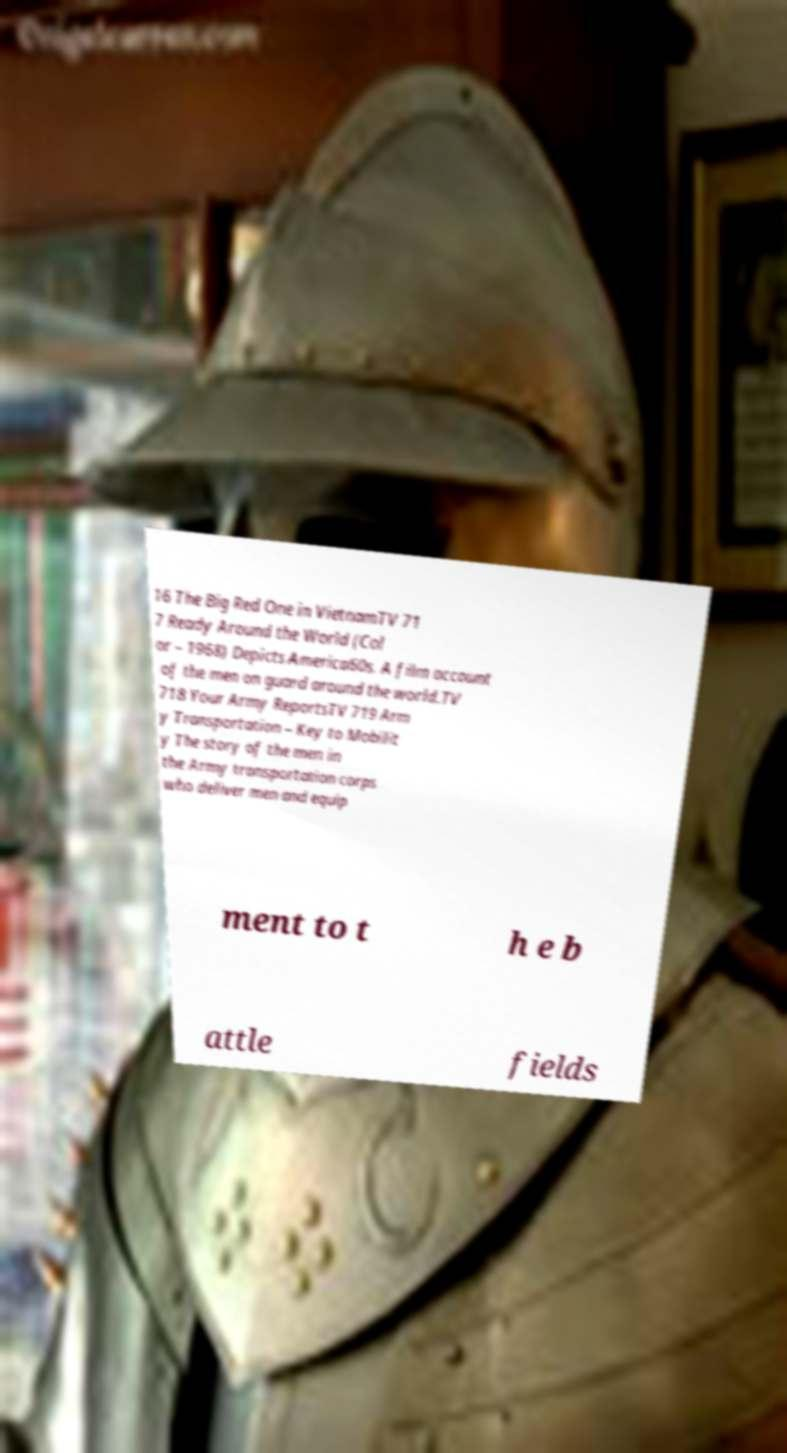Can you read and provide the text displayed in the image?This photo seems to have some interesting text. Can you extract and type it out for me? 16 The Big Red One in VietnamTV 71 7 Ready Around the World (Col or – 1968) Depicts America60s. A film account of the men on guard around the world.TV 718 Your Army ReportsTV 719 Arm y Transportation – Key to Mobilit y The story of the men in the Army transportation corps who deliver men and equip ment to t h e b attle fields 